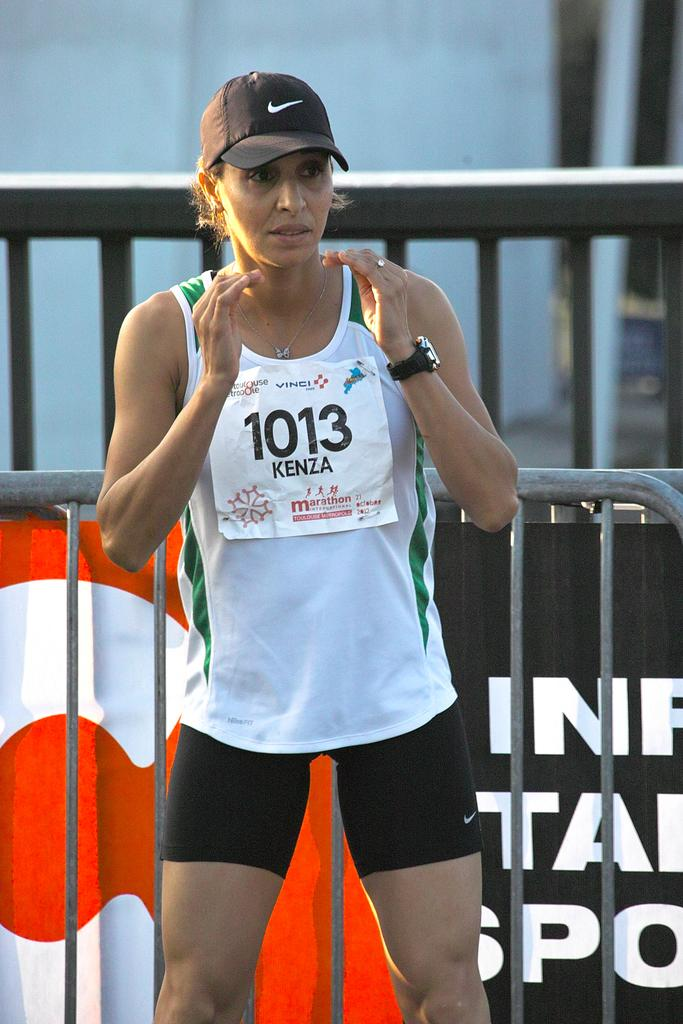<image>
Relay a brief, clear account of the picture shown. A runner wearing a shirt and sign that says Kenza. 